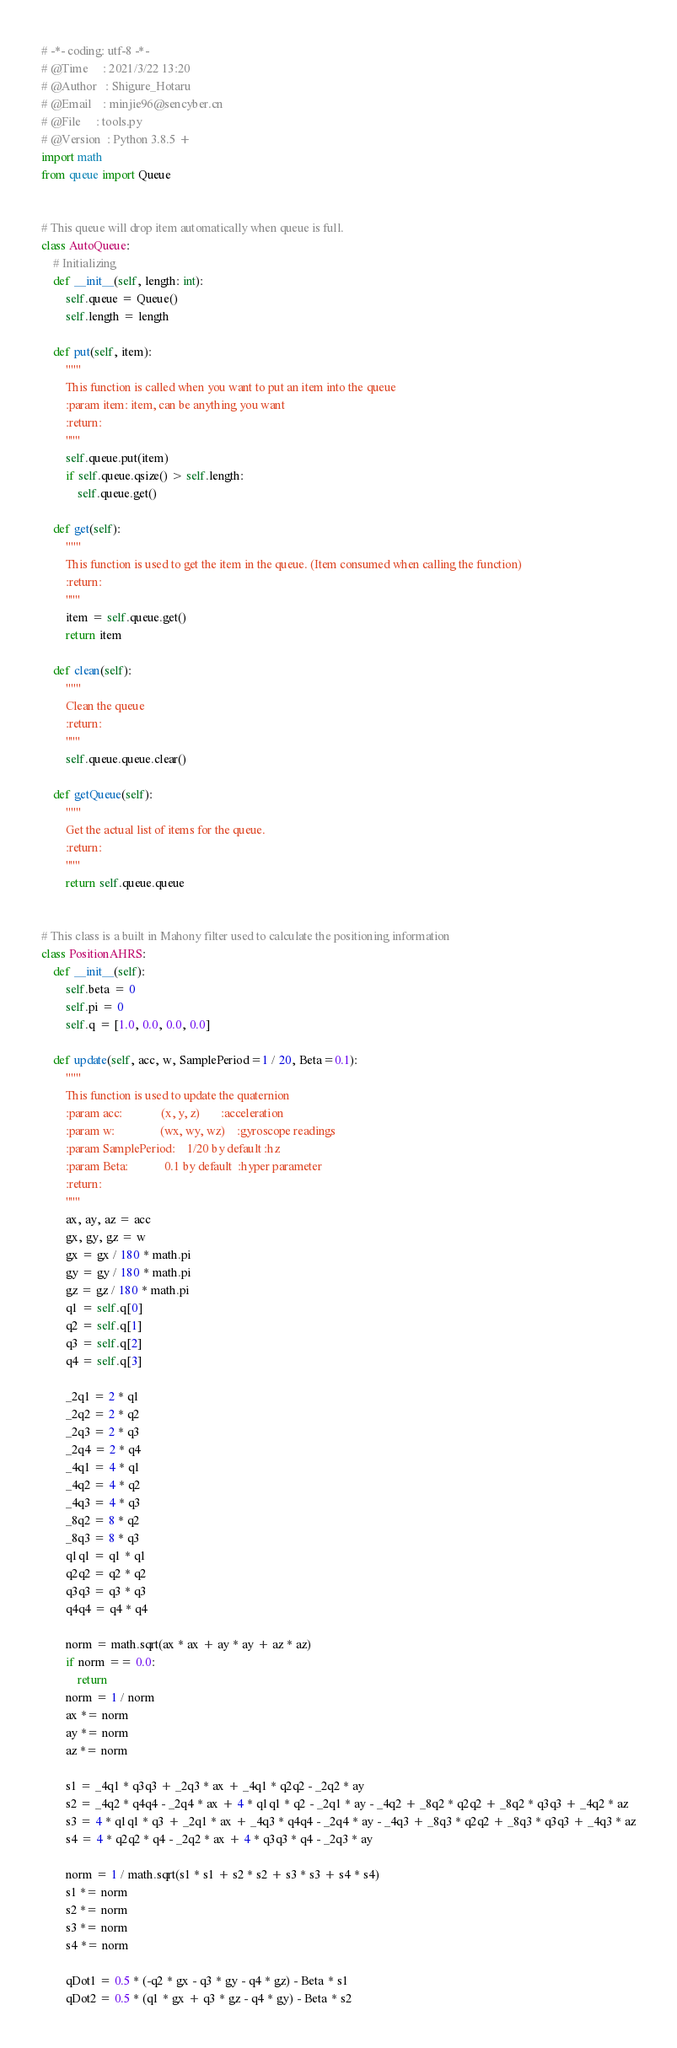Convert code to text. <code><loc_0><loc_0><loc_500><loc_500><_Python_># -*- coding: utf-8 -*-
# @Time     : 2021/3/22 13:20
# @Author   : Shigure_Hotaru
# @Email    : minjie96@sencyber.cn
# @File     : tools.py
# @Version  : Python 3.8.5 +
import math
from queue import Queue


# This queue will drop item automatically when queue is full.
class AutoQueue:
    # Initializing
    def __init__(self, length: int):
        self.queue = Queue()
        self.length = length

    def put(self, item):
        """
        This function is called when you want to put an item into the queue
        :param item: item, can be anything you want
        :return:
        """
        self.queue.put(item)
        if self.queue.qsize() > self.length:
            self.queue.get()

    def get(self):
        """
        This function is used to get the item in the queue. (Item consumed when calling the function)
        :return:
        """
        item = self.queue.get()
        return item

    def clean(self):
        """
        Clean the queue
        :return:
        """
        self.queue.queue.clear()

    def getQueue(self):
        """
        Get the actual list of items for the queue.
        :return:
        """
        return self.queue.queue


# This class is a built in Mahony filter used to calculate the positioning information
class PositionAHRS:
    def __init__(self):
        self.beta = 0
        self.pi = 0
        self.q = [1.0, 0.0, 0.0, 0.0]

    def update(self, acc, w, SamplePeriod=1 / 20, Beta=0.1):
        """
        This function is used to update the quaternion
        :param acc:             (x, y, z)       :acceleration
        :param w:               (wx, wy, wz)    :gyroscope readings
        :param SamplePeriod:    1/20 by default :hz
        :param Beta:            0.1 by default  :hyper parameter
        :return:
        """
        ax, ay, az = acc
        gx, gy, gz = w
        gx = gx / 180 * math.pi
        gy = gy / 180 * math.pi
        gz = gz / 180 * math.pi
        q1 = self.q[0]
        q2 = self.q[1]
        q3 = self.q[2]
        q4 = self.q[3]

        _2q1 = 2 * q1
        _2q2 = 2 * q2
        _2q3 = 2 * q3
        _2q4 = 2 * q4
        _4q1 = 4 * q1
        _4q2 = 4 * q2
        _4q3 = 4 * q3
        _8q2 = 8 * q2
        _8q3 = 8 * q3
        q1q1 = q1 * q1
        q2q2 = q2 * q2
        q3q3 = q3 * q3
        q4q4 = q4 * q4

        norm = math.sqrt(ax * ax + ay * ay + az * az)
        if norm == 0.0:
            return
        norm = 1 / norm
        ax *= norm
        ay *= norm
        az *= norm

        s1 = _4q1 * q3q3 + _2q3 * ax + _4q1 * q2q2 - _2q2 * ay
        s2 = _4q2 * q4q4 - _2q4 * ax + 4 * q1q1 * q2 - _2q1 * ay - _4q2 + _8q2 * q2q2 + _8q2 * q3q3 + _4q2 * az
        s3 = 4 * q1q1 * q3 + _2q1 * ax + _4q3 * q4q4 - _2q4 * ay - _4q3 + _8q3 * q2q2 + _8q3 * q3q3 + _4q3 * az
        s4 = 4 * q2q2 * q4 - _2q2 * ax + 4 * q3q3 * q4 - _2q3 * ay

        norm = 1 / math.sqrt(s1 * s1 + s2 * s2 + s3 * s3 + s4 * s4)
        s1 *= norm
        s2 *= norm
        s3 *= norm
        s4 *= norm

        qDot1 = 0.5 * (-q2 * gx - q3 * gy - q4 * gz) - Beta * s1
        qDot2 = 0.5 * (q1 * gx + q3 * gz - q4 * gy) - Beta * s2</code> 